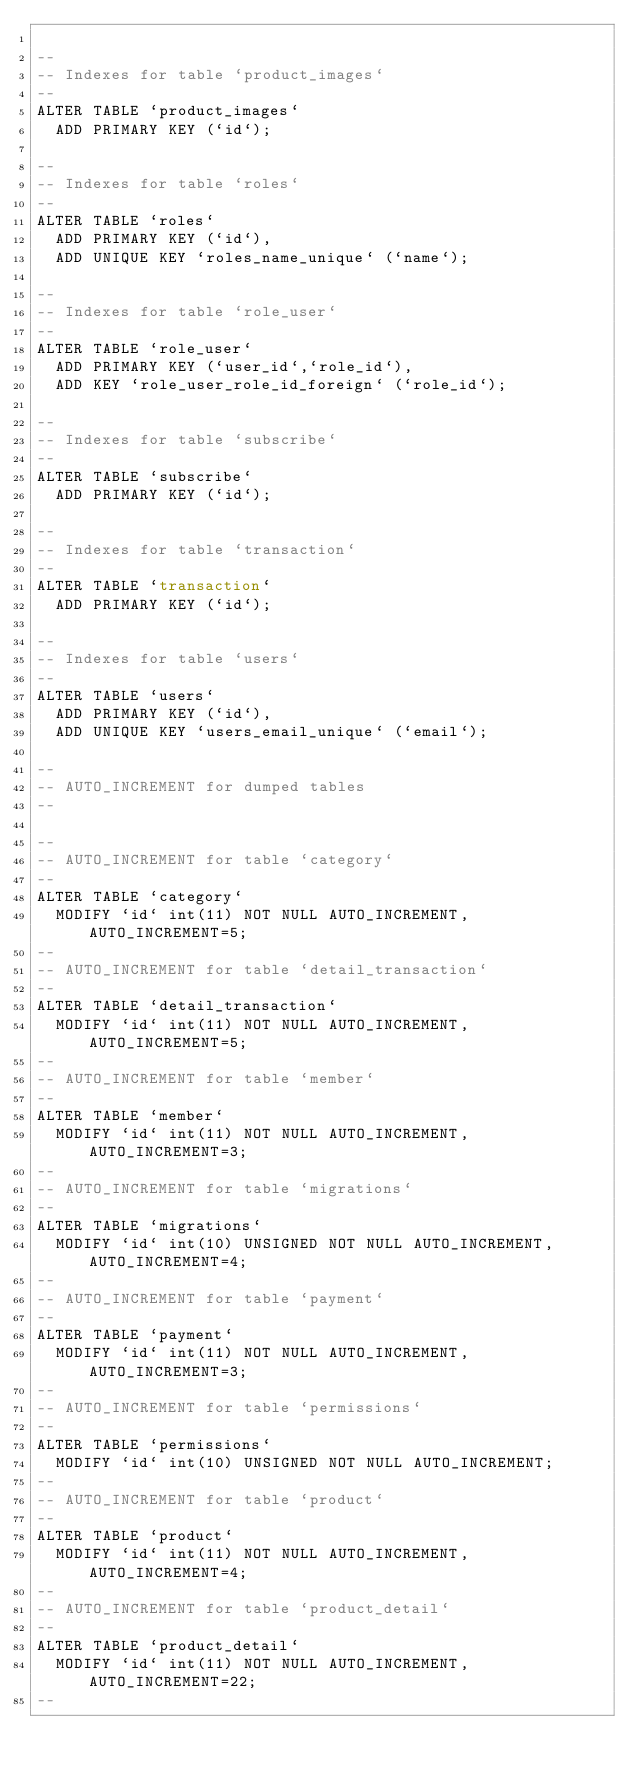<code> <loc_0><loc_0><loc_500><loc_500><_SQL_>
--
-- Indexes for table `product_images`
--
ALTER TABLE `product_images`
  ADD PRIMARY KEY (`id`);

--
-- Indexes for table `roles`
--
ALTER TABLE `roles`
  ADD PRIMARY KEY (`id`),
  ADD UNIQUE KEY `roles_name_unique` (`name`);

--
-- Indexes for table `role_user`
--
ALTER TABLE `role_user`
  ADD PRIMARY KEY (`user_id`,`role_id`),
  ADD KEY `role_user_role_id_foreign` (`role_id`);

--
-- Indexes for table `subscribe`
--
ALTER TABLE `subscribe`
  ADD PRIMARY KEY (`id`);

--
-- Indexes for table `transaction`
--
ALTER TABLE `transaction`
  ADD PRIMARY KEY (`id`);

--
-- Indexes for table `users`
--
ALTER TABLE `users`
  ADD PRIMARY KEY (`id`),
  ADD UNIQUE KEY `users_email_unique` (`email`);

--
-- AUTO_INCREMENT for dumped tables
--

--
-- AUTO_INCREMENT for table `category`
--
ALTER TABLE `category`
  MODIFY `id` int(11) NOT NULL AUTO_INCREMENT, AUTO_INCREMENT=5;
--
-- AUTO_INCREMENT for table `detail_transaction`
--
ALTER TABLE `detail_transaction`
  MODIFY `id` int(11) NOT NULL AUTO_INCREMENT, AUTO_INCREMENT=5;
--
-- AUTO_INCREMENT for table `member`
--
ALTER TABLE `member`
  MODIFY `id` int(11) NOT NULL AUTO_INCREMENT, AUTO_INCREMENT=3;
--
-- AUTO_INCREMENT for table `migrations`
--
ALTER TABLE `migrations`
  MODIFY `id` int(10) UNSIGNED NOT NULL AUTO_INCREMENT, AUTO_INCREMENT=4;
--
-- AUTO_INCREMENT for table `payment`
--
ALTER TABLE `payment`
  MODIFY `id` int(11) NOT NULL AUTO_INCREMENT, AUTO_INCREMENT=3;
--
-- AUTO_INCREMENT for table `permissions`
--
ALTER TABLE `permissions`
  MODIFY `id` int(10) UNSIGNED NOT NULL AUTO_INCREMENT;
--
-- AUTO_INCREMENT for table `product`
--
ALTER TABLE `product`
  MODIFY `id` int(11) NOT NULL AUTO_INCREMENT, AUTO_INCREMENT=4;
--
-- AUTO_INCREMENT for table `product_detail`
--
ALTER TABLE `product_detail`
  MODIFY `id` int(11) NOT NULL AUTO_INCREMENT, AUTO_INCREMENT=22;
--</code> 